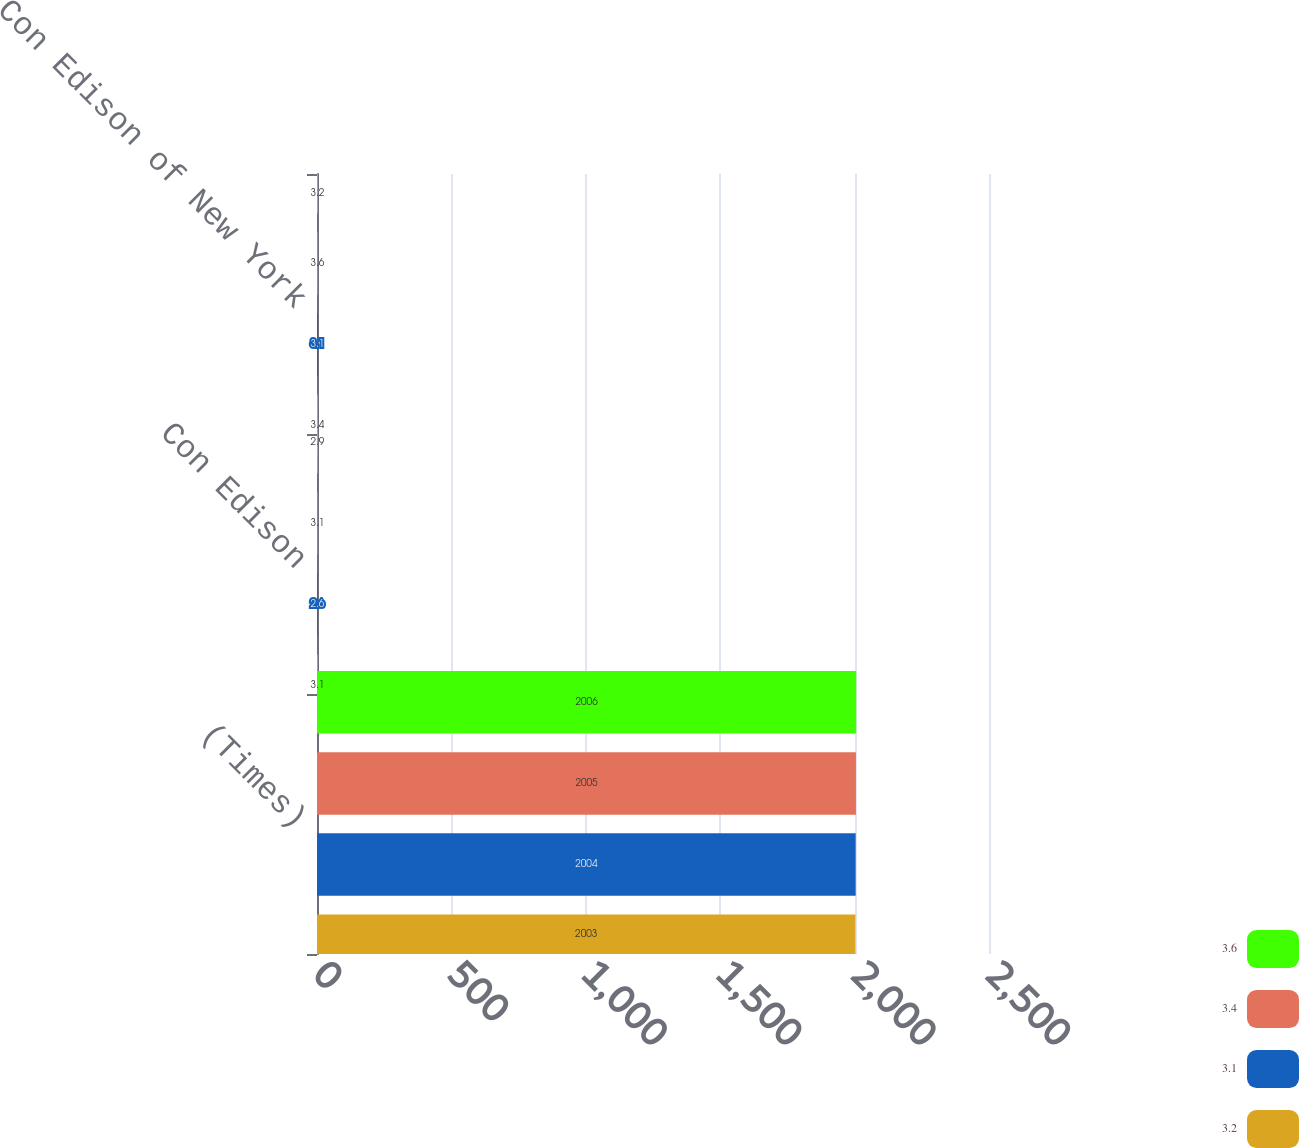<chart> <loc_0><loc_0><loc_500><loc_500><stacked_bar_chart><ecel><fcel>(Times)<fcel>Con Edison<fcel>Con Edison of New York<nl><fcel>3.6<fcel>2006<fcel>2.9<fcel>3.2<nl><fcel>3.4<fcel>2005<fcel>3.1<fcel>3.6<nl><fcel>3.1<fcel>2004<fcel>2.6<fcel>3.1<nl><fcel>3.2<fcel>2003<fcel>3.1<fcel>3.4<nl></chart> 